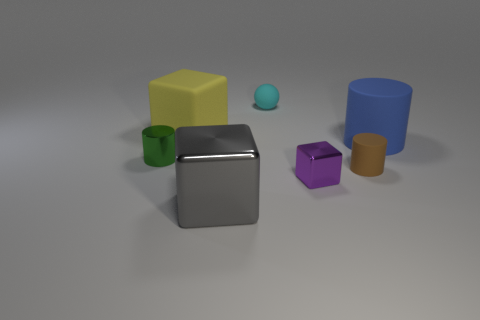How many objects are small metal blocks or tiny gray rubber blocks?
Provide a short and direct response. 1. Are there fewer small green objects that are to the right of the big matte cylinder than small blue rubber objects?
Provide a short and direct response. No. Are there more big matte cylinders to the right of the big blue cylinder than tiny metallic objects right of the cyan rubber object?
Keep it short and to the point. No. There is a thing that is in front of the small metal block; what material is it?
Your answer should be very brief. Metal. Is the green object the same size as the blue cylinder?
Make the answer very short. No. What number of other things are the same size as the gray shiny thing?
Provide a succinct answer. 2. What is the shape of the large rubber object to the right of the block that is behind the tiny metal object behind the tiny brown matte cylinder?
Offer a terse response. Cylinder. What number of things are rubber things that are in front of the yellow rubber block or cubes right of the large gray metal cube?
Ensure brevity in your answer.  3. There is a metal object behind the small object that is to the right of the tiny purple object; how big is it?
Ensure brevity in your answer.  Small. Are there any brown matte objects of the same shape as the large blue object?
Ensure brevity in your answer.  Yes. 